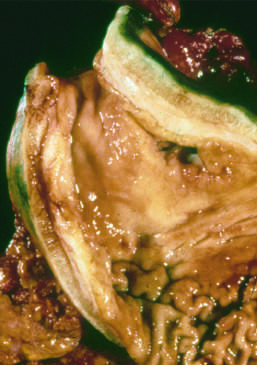what is markedly thickened?
Answer the question using a single word or phrase. The gastric wall 